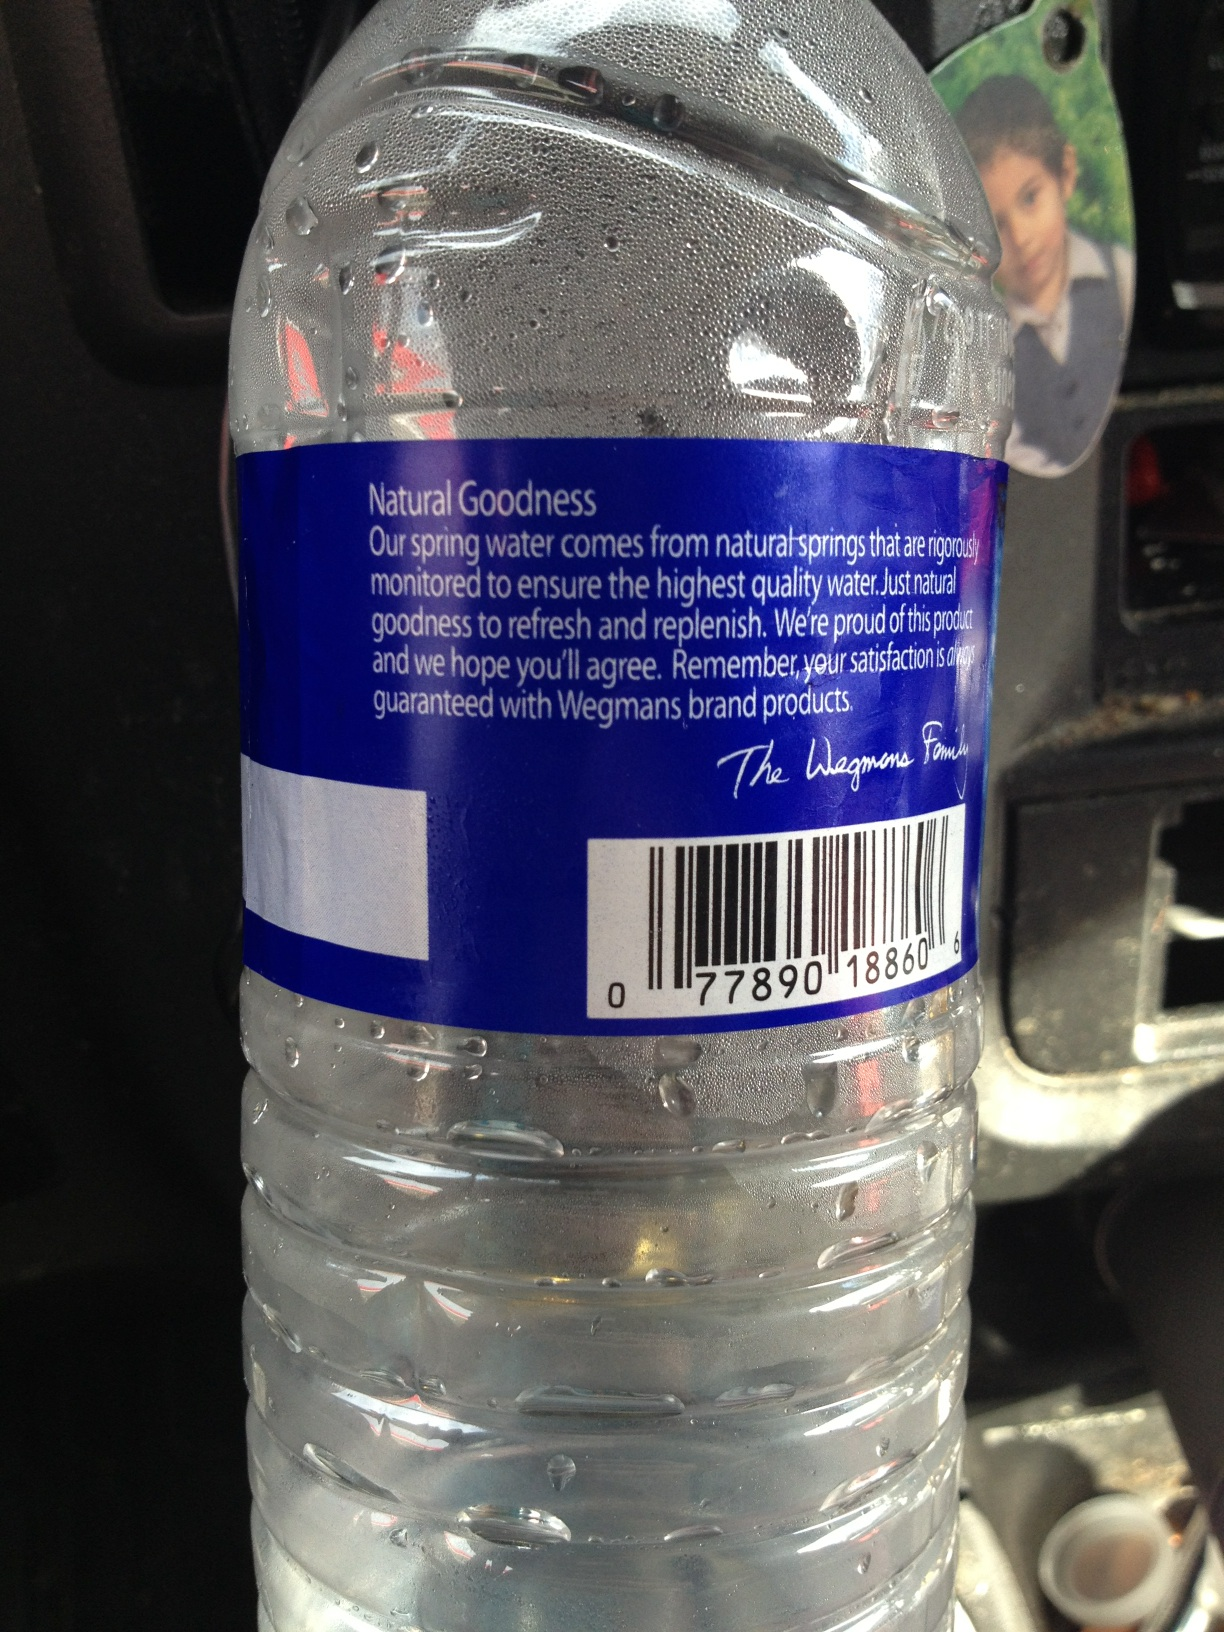What brand is this water bottle? This water bottle is branded under Wegmans. It is a spring water product, marketed for its natural goodness and high-quality standards. 